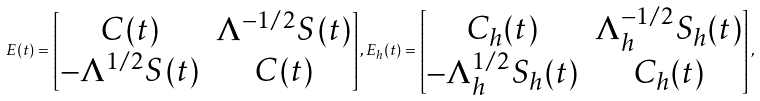Convert formula to latex. <formula><loc_0><loc_0><loc_500><loc_500>E ( t ) = \begin{bmatrix} C ( t ) & \Lambda ^ { - 1 / 2 } S ( t ) \\ - \Lambda ^ { 1 / 2 } S ( t ) & C ( t ) \end{bmatrix} , E _ { h } ( t ) = \begin{bmatrix} C _ { h } ( t ) & \Lambda _ { h } ^ { - 1 / 2 } S _ { h } ( t ) \\ - \Lambda _ { h } ^ { 1 / 2 } S _ { h } ( t ) & C _ { h } ( t ) \end{bmatrix} ,</formula> 